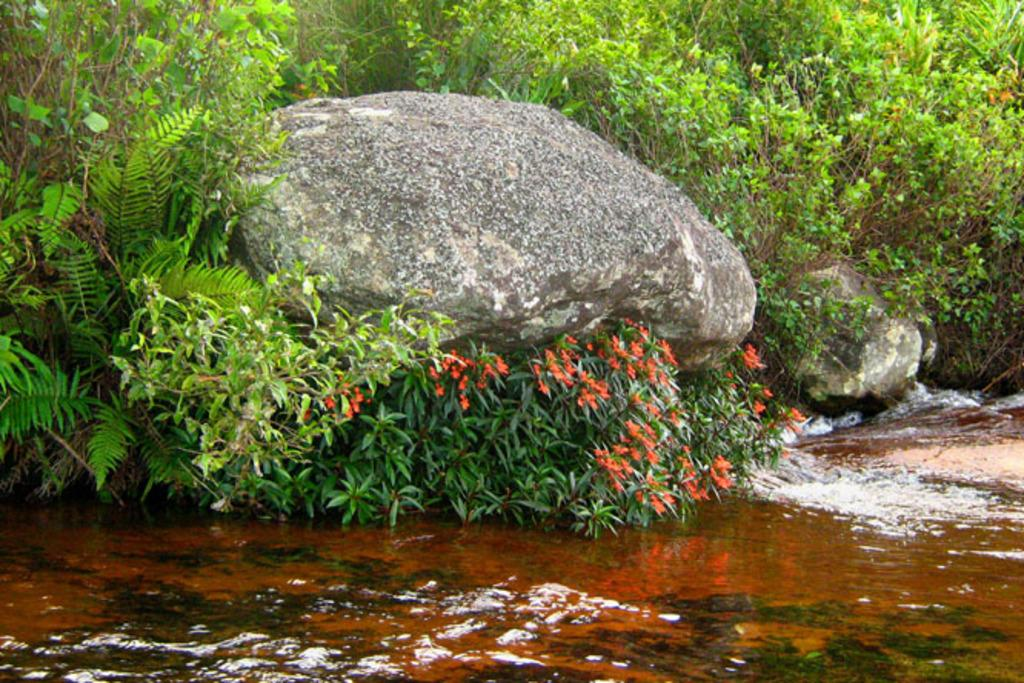What is the primary element visible in the image? There is water in the image. What types of plants can be seen in the image? There are flowering plants and trees in the image. What other objects are present in the image? There are rocks in the image. Can you determine the time of day the image was taken? The image was likely taken during the day, as there is sufficient light to see the details. What type of boot is being used to perform arithmetic calculations in the image? There is no boot or arithmetic calculations present in the image. 